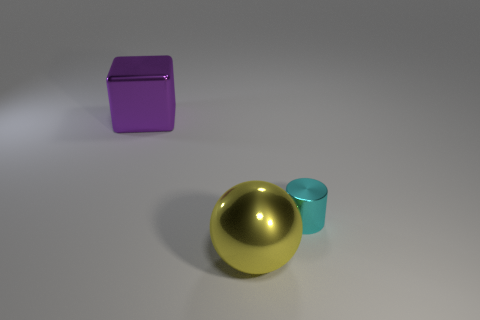Subtract all cyan cubes. Subtract all blue balls. How many cubes are left? 1 Add 2 large blocks. How many objects exist? 5 Subtract all balls. How many objects are left? 2 Add 1 cyan metallic cylinders. How many cyan metallic cylinders exist? 2 Subtract 0 red cylinders. How many objects are left? 3 Subtract all spheres. Subtract all large brown rubber balls. How many objects are left? 2 Add 1 big blocks. How many big blocks are left? 2 